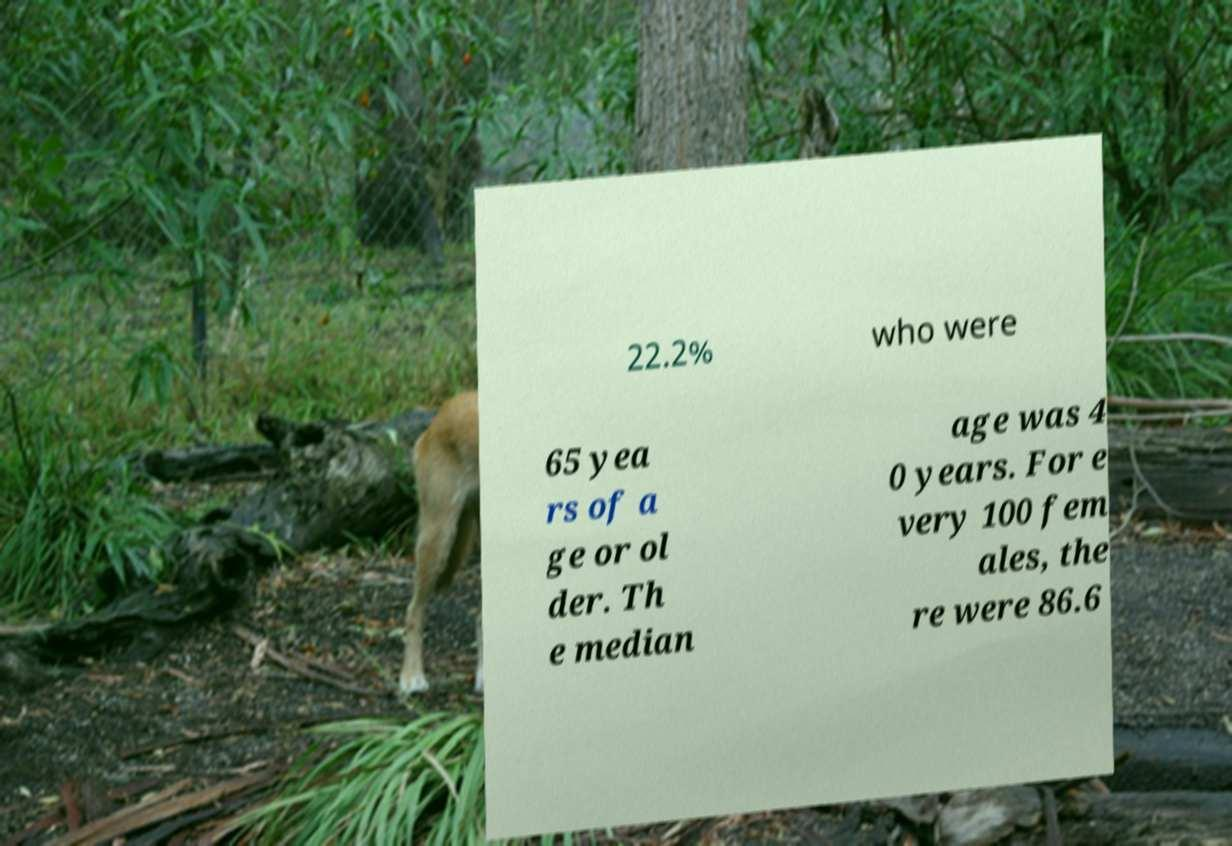Please identify and transcribe the text found in this image. 22.2% who were 65 yea rs of a ge or ol der. Th e median age was 4 0 years. For e very 100 fem ales, the re were 86.6 